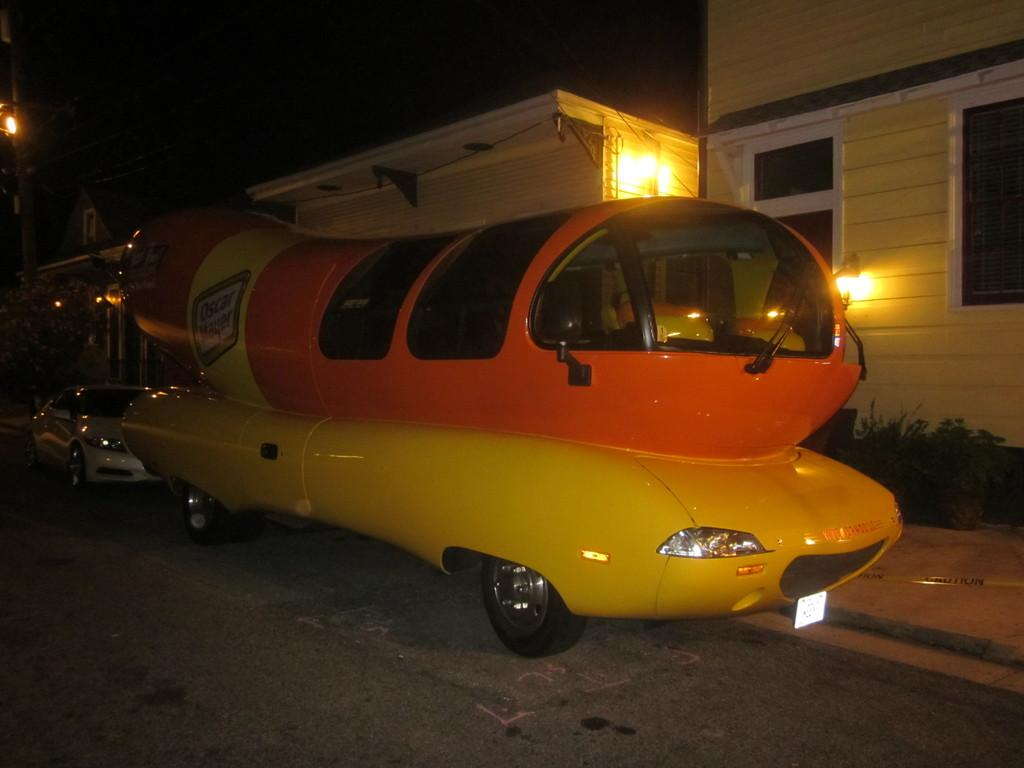What type of vehicle can be seen in the image? There is a car in the image. Are there any other vehicles present? Yes, there is another vehicle in the image. Where are the vehicles located? Both vehicles are on the road. What else can be seen in the image besides the vehicles? There are buildings, lights, and plants visible in the image. Are there any flames visible in the image? No, there are no flames present in the image. What type of cactus can be seen growing among the plants in the image? There is no cactus present in the image; only plants are visible. 